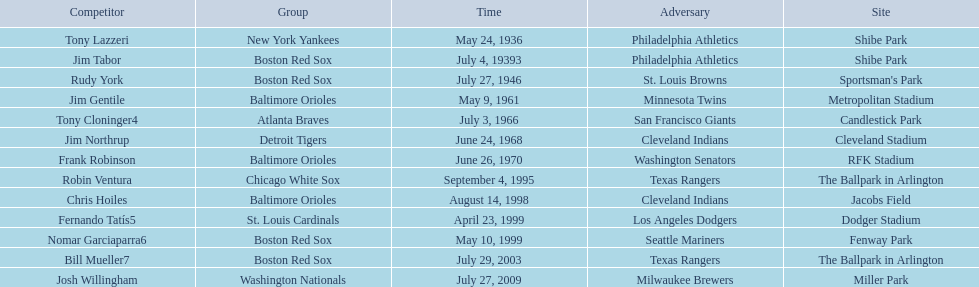What are the dates? May 24, 1936, July 4, 19393, July 27, 1946, May 9, 1961, July 3, 1966, June 24, 1968, June 26, 1970, September 4, 1995, August 14, 1998, April 23, 1999, May 10, 1999, July 29, 2003, July 27, 2009. Which date is in 1936? May 24, 1936. What player is listed for this date? Tony Lazzeri. 